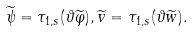Convert formula to latex. <formula><loc_0><loc_0><loc_500><loc_500>\widetilde { \psi } = \tau _ { 1 , s } ( \vartheta \widetilde { \varphi } ) , \widetilde { v } = \tau _ { 1 , s } ( \vartheta \widetilde { w } ) .</formula> 